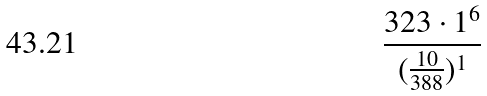Convert formula to latex. <formula><loc_0><loc_0><loc_500><loc_500>\frac { 3 2 3 \cdot 1 ^ { 6 } } { ( \frac { 1 0 } { 3 8 8 } ) ^ { 1 } }</formula> 